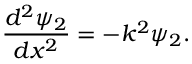Convert formula to latex. <formula><loc_0><loc_0><loc_500><loc_500>{ \frac { d ^ { 2 } \psi _ { 2 } } { d x ^ { 2 } } } = - k ^ { 2 } \psi _ { 2 } .</formula> 